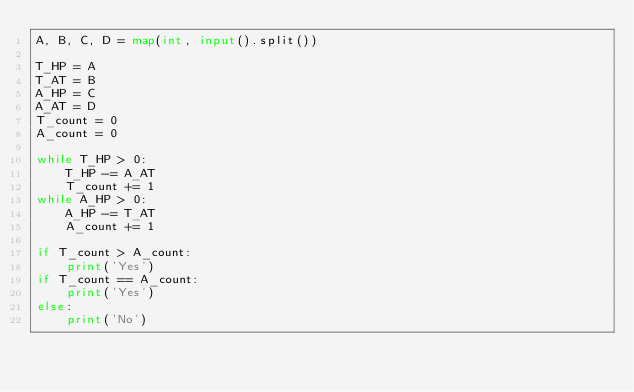Convert code to text. <code><loc_0><loc_0><loc_500><loc_500><_Python_>A, B, C, D = map(int, input().split())

T_HP = A
T_AT = B
A_HP = C
A_AT = D
T_count = 0
A_count = 0

while T_HP > 0:
    T_HP -= A_AT
    T_count += 1
while A_HP > 0:
    A_HP -= T_AT
    A_count += 1
    
if T_count > A_count:
    print('Yes')
if T_count == A_count:
    print('Yes')
else:
    print('No')</code> 